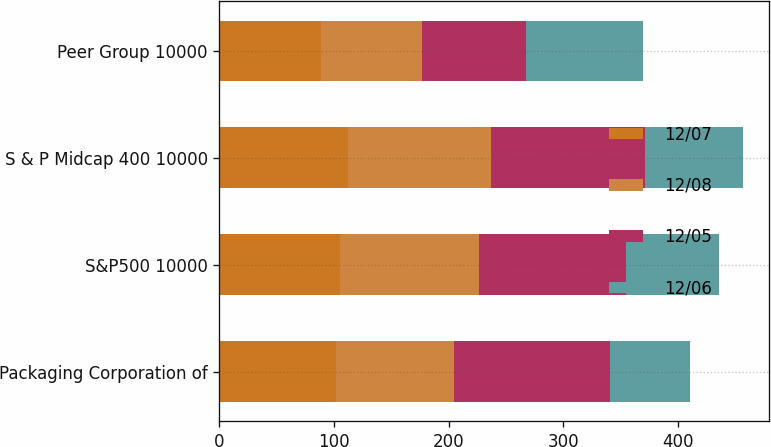<chart> <loc_0><loc_0><loc_500><loc_500><stacked_bar_chart><ecel><fcel>Packaging Corporation of<fcel>S&P500 10000<fcel>S & P Midcap 400 10000<fcel>Peer Group 10000<nl><fcel>12/07<fcel>101.89<fcel>104.91<fcel>112.55<fcel>88.23<nl><fcel>12/08<fcel>102.63<fcel>121.48<fcel>124.17<fcel>88.52<nl><fcel>12/05<fcel>136.35<fcel>128.16<fcel>134.08<fcel>90.16<nl><fcel>12/06<fcel>69.23<fcel>80.74<fcel>85.5<fcel>102.63<nl></chart> 